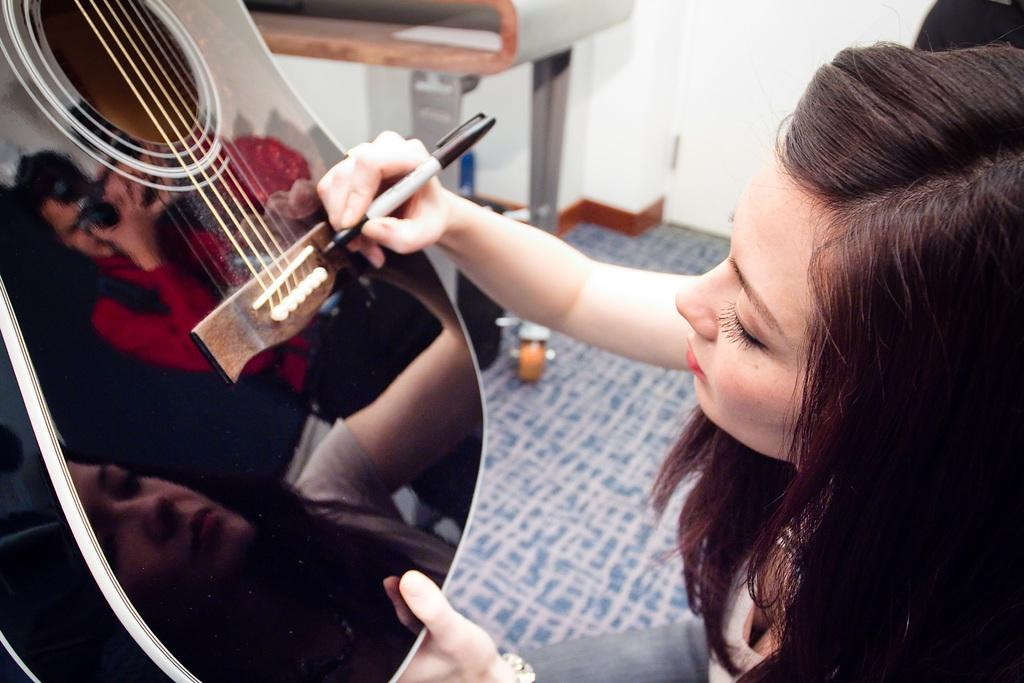Who is the main subject in the image? There is a lady in the image. What is the lady doing in the image? The lady is writing something on a guitar. What type of knife is the lady using to write on the guitar in the image? There is no knife present in the image; the lady is using a writing instrument to write on the guitar. How many bikes can be seen in the image? There are no bikes present in the image. 